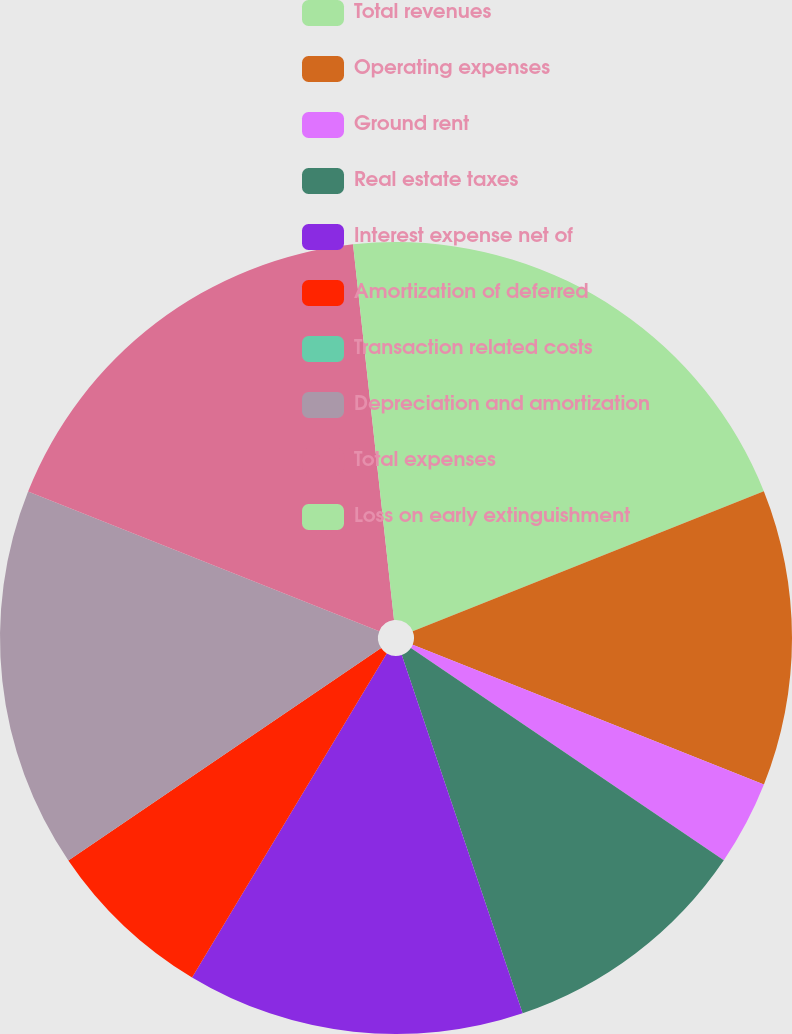Convert chart to OTSL. <chart><loc_0><loc_0><loc_500><loc_500><pie_chart><fcel>Total revenues<fcel>Operating expenses<fcel>Ground rent<fcel>Real estate taxes<fcel>Interest expense net of<fcel>Amortization of deferred<fcel>Transaction related costs<fcel>Depreciation and amortization<fcel>Total expenses<fcel>Loss on early extinguishment<nl><fcel>18.96%<fcel>12.07%<fcel>3.45%<fcel>10.34%<fcel>13.79%<fcel>6.9%<fcel>0.0%<fcel>15.52%<fcel>17.24%<fcel>1.73%<nl></chart> 